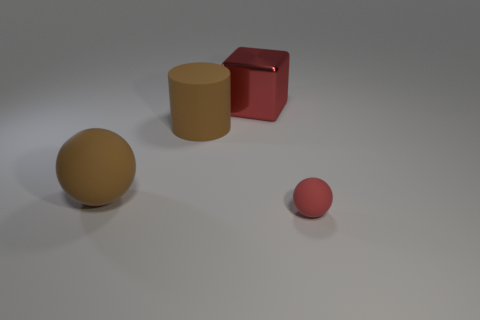Is the number of big rubber objects less than the number of small purple shiny cubes?
Give a very brief answer. No. What is the material of the block that is the same size as the brown matte ball?
Provide a short and direct response. Metal. There is a matte ball that is behind the tiny thing; is it the same size as the rubber ball that is to the right of the large sphere?
Offer a very short reply. No. Are there any big red objects made of the same material as the brown ball?
Your answer should be very brief. No. What number of things are either large things in front of the red block or big rubber balls?
Your answer should be compact. 2. Does the red thing that is in front of the cylinder have the same material as the brown sphere?
Offer a terse response. Yes. Is the tiny rubber thing the same shape as the metallic object?
Make the answer very short. No. How many big brown objects are to the right of the big red metallic cube behind the large rubber cylinder?
Make the answer very short. 0. There is another object that is the same shape as the small red object; what material is it?
Offer a very short reply. Rubber. There is a large rubber object behind the large brown sphere; is it the same color as the metal block?
Your response must be concise. No. 